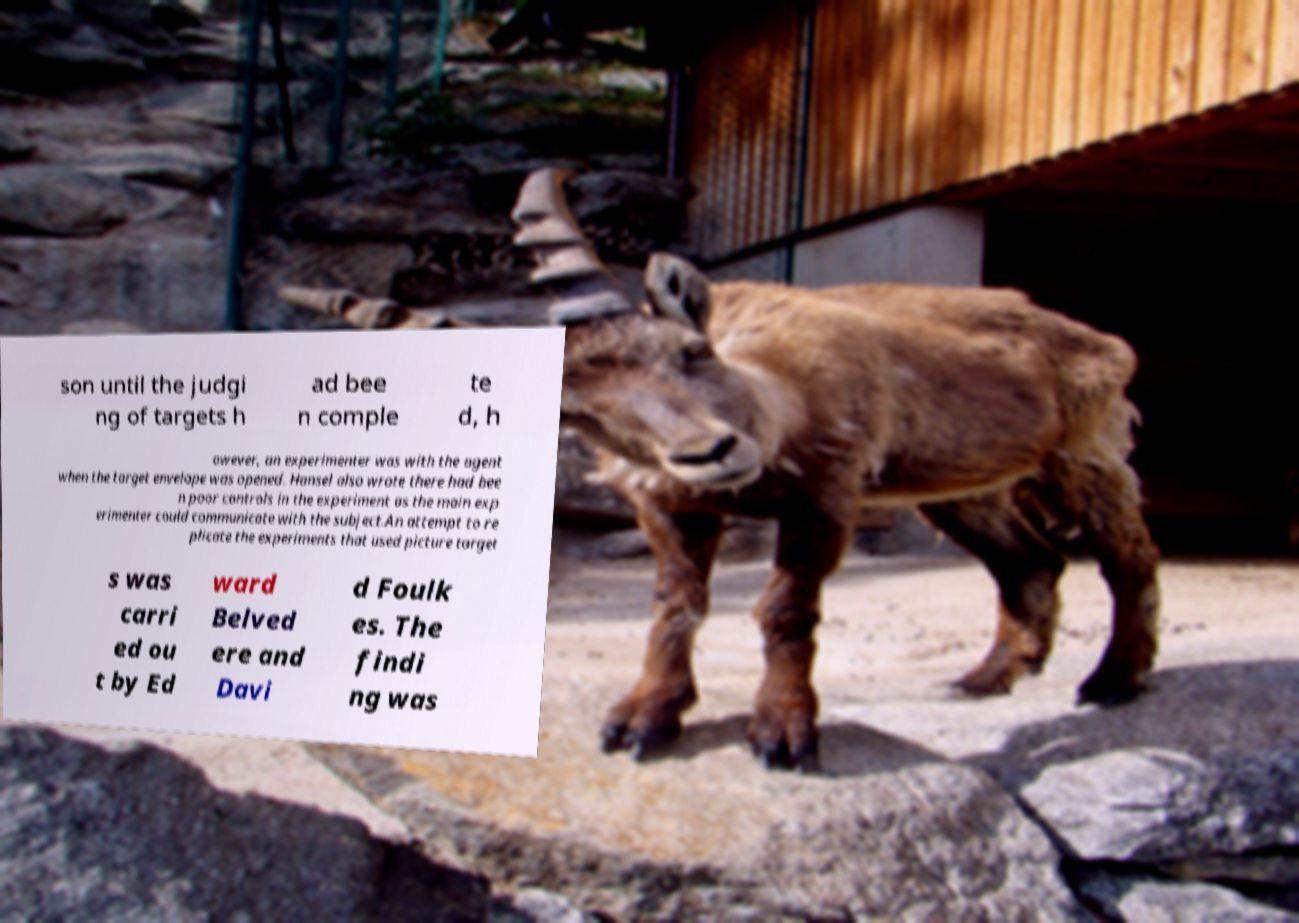Please read and relay the text visible in this image. What does it say? son until the judgi ng of targets h ad bee n comple te d, h owever, an experimenter was with the agent when the target envelope was opened. Hansel also wrote there had bee n poor controls in the experiment as the main exp erimenter could communicate with the subject.An attempt to re plicate the experiments that used picture target s was carri ed ou t by Ed ward Belved ere and Davi d Foulk es. The findi ng was 